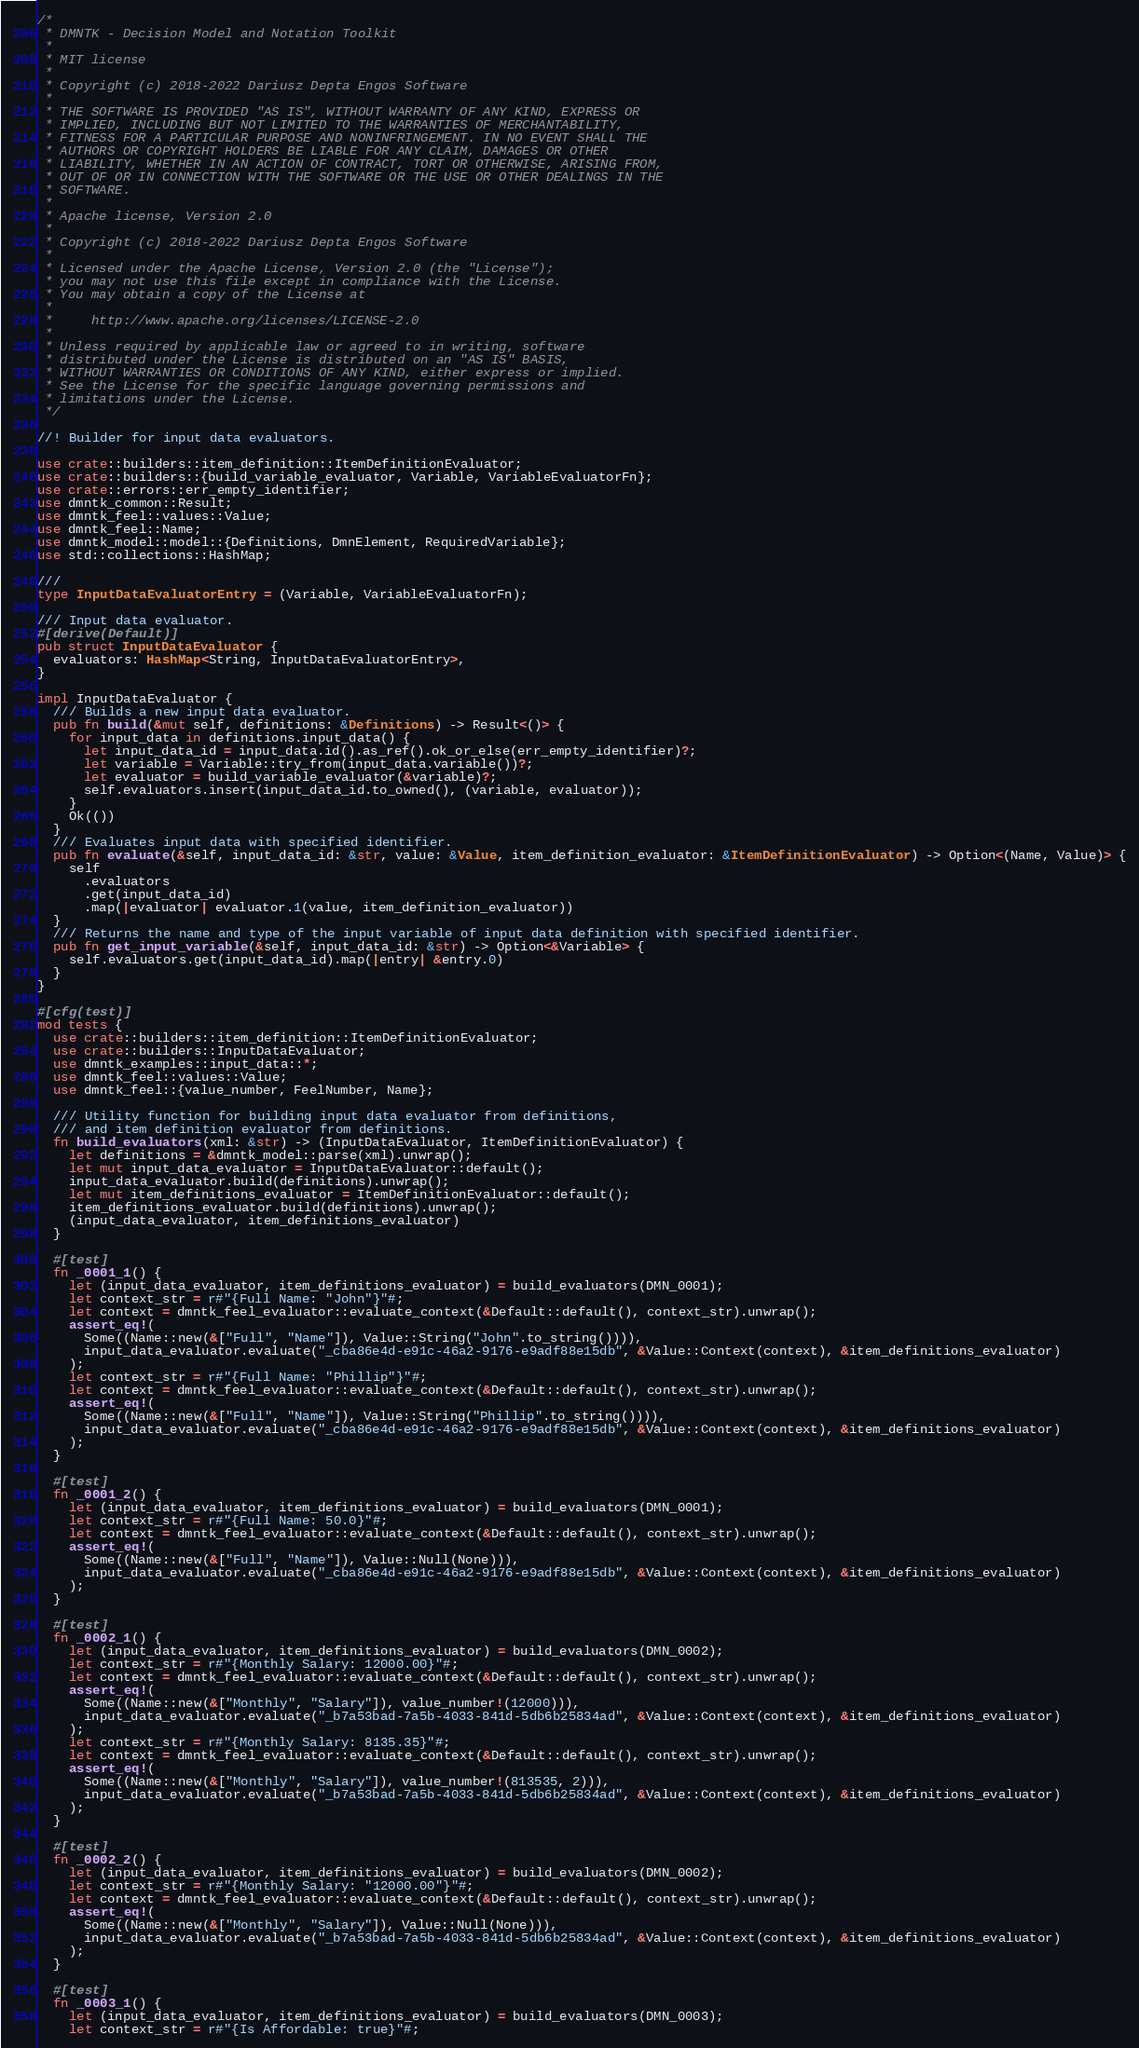<code> <loc_0><loc_0><loc_500><loc_500><_Rust_>/*
 * DMNTK - Decision Model and Notation Toolkit
 *
 * MIT license
 *
 * Copyright (c) 2018-2022 Dariusz Depta Engos Software
 *
 * THE SOFTWARE IS PROVIDED "AS IS", WITHOUT WARRANTY OF ANY KIND, EXPRESS OR
 * IMPLIED, INCLUDING BUT NOT LIMITED TO THE WARRANTIES OF MERCHANTABILITY,
 * FITNESS FOR A PARTICULAR PURPOSE AND NONINFRINGEMENT. IN NO EVENT SHALL THE
 * AUTHORS OR COPYRIGHT HOLDERS BE LIABLE FOR ANY CLAIM, DAMAGES OR OTHER
 * LIABILITY, WHETHER IN AN ACTION OF CONTRACT, TORT OR OTHERWISE, ARISING FROM,
 * OUT OF OR IN CONNECTION WITH THE SOFTWARE OR THE USE OR OTHER DEALINGS IN THE
 * SOFTWARE.
 *
 * Apache license, Version 2.0
 *
 * Copyright (c) 2018-2022 Dariusz Depta Engos Software
 *
 * Licensed under the Apache License, Version 2.0 (the "License");
 * you may not use this file except in compliance with the License.
 * You may obtain a copy of the License at
 *
 *     http://www.apache.org/licenses/LICENSE-2.0
 *
 * Unless required by applicable law or agreed to in writing, software
 * distributed under the License is distributed on an "AS IS" BASIS,
 * WITHOUT WARRANTIES OR CONDITIONS OF ANY KIND, either express or implied.
 * See the License for the specific language governing permissions and
 * limitations under the License.
 */

//! Builder for input data evaluators.

use crate::builders::item_definition::ItemDefinitionEvaluator;
use crate::builders::{build_variable_evaluator, Variable, VariableEvaluatorFn};
use crate::errors::err_empty_identifier;
use dmntk_common::Result;
use dmntk_feel::values::Value;
use dmntk_feel::Name;
use dmntk_model::model::{Definitions, DmnElement, RequiredVariable};
use std::collections::HashMap;

///
type InputDataEvaluatorEntry = (Variable, VariableEvaluatorFn);

/// Input data evaluator.
#[derive(Default)]
pub struct InputDataEvaluator {
  evaluators: HashMap<String, InputDataEvaluatorEntry>,
}

impl InputDataEvaluator {
  /// Builds a new input data evaluator.
  pub fn build(&mut self, definitions: &Definitions) -> Result<()> {
    for input_data in definitions.input_data() {
      let input_data_id = input_data.id().as_ref().ok_or_else(err_empty_identifier)?;
      let variable = Variable::try_from(input_data.variable())?;
      let evaluator = build_variable_evaluator(&variable)?;
      self.evaluators.insert(input_data_id.to_owned(), (variable, evaluator));
    }
    Ok(())
  }
  /// Evaluates input data with specified identifier.
  pub fn evaluate(&self, input_data_id: &str, value: &Value, item_definition_evaluator: &ItemDefinitionEvaluator) -> Option<(Name, Value)> {
    self
      .evaluators
      .get(input_data_id)
      .map(|evaluator| evaluator.1(value, item_definition_evaluator))
  }
  /// Returns the name and type of the input variable of input data definition with specified identifier.
  pub fn get_input_variable(&self, input_data_id: &str) -> Option<&Variable> {
    self.evaluators.get(input_data_id).map(|entry| &entry.0)
  }
}

#[cfg(test)]
mod tests {
  use crate::builders::item_definition::ItemDefinitionEvaluator;
  use crate::builders::InputDataEvaluator;
  use dmntk_examples::input_data::*;
  use dmntk_feel::values::Value;
  use dmntk_feel::{value_number, FeelNumber, Name};

  /// Utility function for building input data evaluator from definitions,
  /// and item definition evaluator from definitions.
  fn build_evaluators(xml: &str) -> (InputDataEvaluator, ItemDefinitionEvaluator) {
    let definitions = &dmntk_model::parse(xml).unwrap();
    let mut input_data_evaluator = InputDataEvaluator::default();
    input_data_evaluator.build(definitions).unwrap();
    let mut item_definitions_evaluator = ItemDefinitionEvaluator::default();
    item_definitions_evaluator.build(definitions).unwrap();
    (input_data_evaluator, item_definitions_evaluator)
  }

  #[test]
  fn _0001_1() {
    let (input_data_evaluator, item_definitions_evaluator) = build_evaluators(DMN_0001);
    let context_str = r#"{Full Name: "John"}"#;
    let context = dmntk_feel_evaluator::evaluate_context(&Default::default(), context_str).unwrap();
    assert_eq!(
      Some((Name::new(&["Full", "Name"]), Value::String("John".to_string()))),
      input_data_evaluator.evaluate("_cba86e4d-e91c-46a2-9176-e9adf88e15db", &Value::Context(context), &item_definitions_evaluator)
    );
    let context_str = r#"{Full Name: "Phillip"}"#;
    let context = dmntk_feel_evaluator::evaluate_context(&Default::default(), context_str).unwrap();
    assert_eq!(
      Some((Name::new(&["Full", "Name"]), Value::String("Phillip".to_string()))),
      input_data_evaluator.evaluate("_cba86e4d-e91c-46a2-9176-e9adf88e15db", &Value::Context(context), &item_definitions_evaluator)
    );
  }

  #[test]
  fn _0001_2() {
    let (input_data_evaluator, item_definitions_evaluator) = build_evaluators(DMN_0001);
    let context_str = r#"{Full Name: 50.0}"#;
    let context = dmntk_feel_evaluator::evaluate_context(&Default::default(), context_str).unwrap();
    assert_eq!(
      Some((Name::new(&["Full", "Name"]), Value::Null(None))),
      input_data_evaluator.evaluate("_cba86e4d-e91c-46a2-9176-e9adf88e15db", &Value::Context(context), &item_definitions_evaluator)
    );
  }

  #[test]
  fn _0002_1() {
    let (input_data_evaluator, item_definitions_evaluator) = build_evaluators(DMN_0002);
    let context_str = r#"{Monthly Salary: 12000.00}"#;
    let context = dmntk_feel_evaluator::evaluate_context(&Default::default(), context_str).unwrap();
    assert_eq!(
      Some((Name::new(&["Monthly", "Salary"]), value_number!(12000))),
      input_data_evaluator.evaluate("_b7a53bad-7a5b-4033-841d-5db6b25834ad", &Value::Context(context), &item_definitions_evaluator)
    );
    let context_str = r#"{Monthly Salary: 8135.35}"#;
    let context = dmntk_feel_evaluator::evaluate_context(&Default::default(), context_str).unwrap();
    assert_eq!(
      Some((Name::new(&["Monthly", "Salary"]), value_number!(813535, 2))),
      input_data_evaluator.evaluate("_b7a53bad-7a5b-4033-841d-5db6b25834ad", &Value::Context(context), &item_definitions_evaluator)
    );
  }

  #[test]
  fn _0002_2() {
    let (input_data_evaluator, item_definitions_evaluator) = build_evaluators(DMN_0002);
    let context_str = r#"{Monthly Salary: "12000.00"}"#;
    let context = dmntk_feel_evaluator::evaluate_context(&Default::default(), context_str).unwrap();
    assert_eq!(
      Some((Name::new(&["Monthly", "Salary"]), Value::Null(None))),
      input_data_evaluator.evaluate("_b7a53bad-7a5b-4033-841d-5db6b25834ad", &Value::Context(context), &item_definitions_evaluator)
    );
  }

  #[test]
  fn _0003_1() {
    let (input_data_evaluator, item_definitions_evaluator) = build_evaluators(DMN_0003);
    let context_str = r#"{Is Affordable: true}"#;</code> 